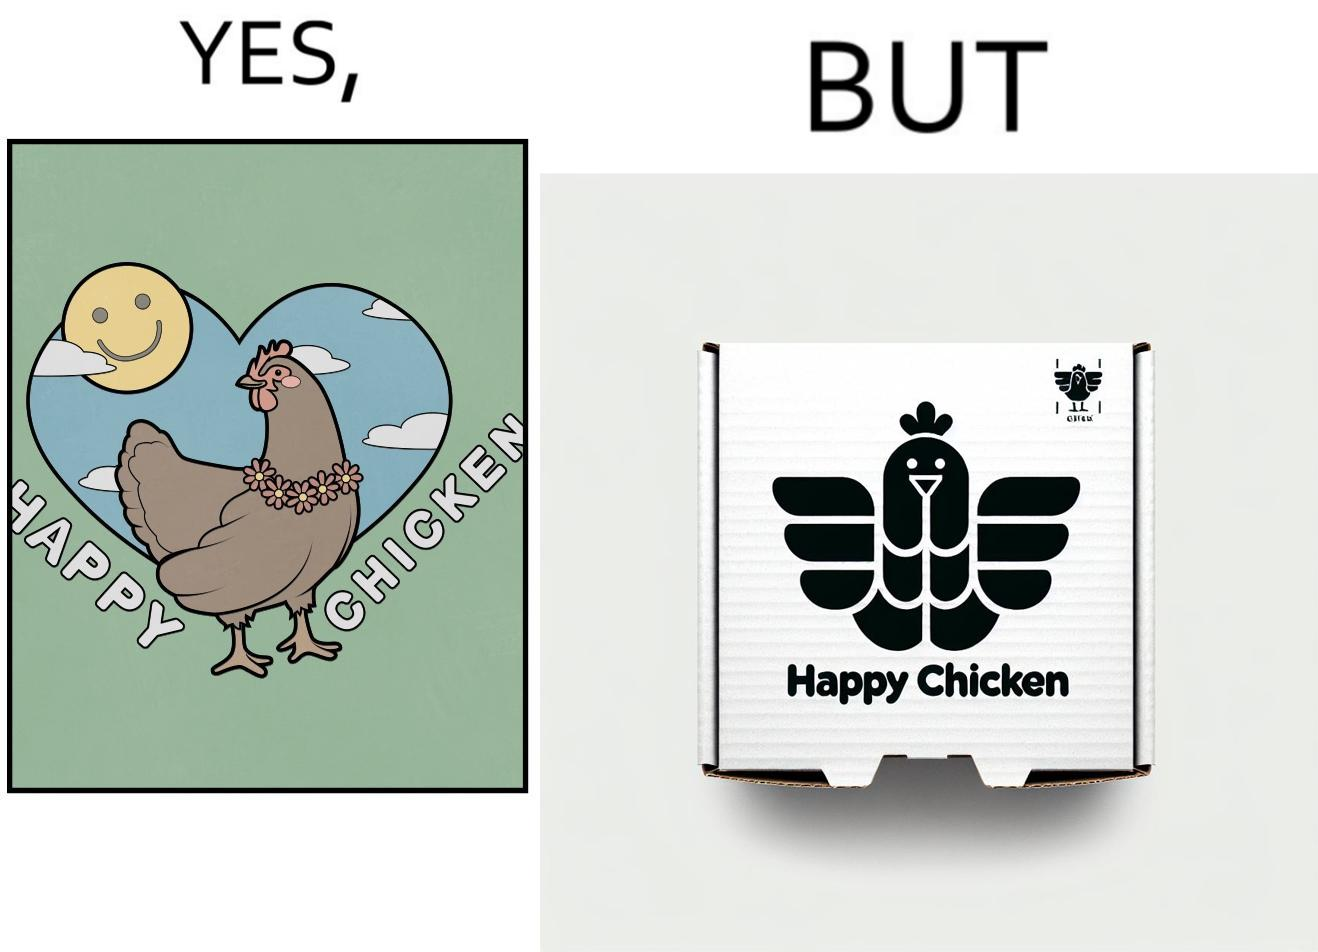Provide a description of this image. The image is ironic, because in the left image as in the logo it shows happy chicken but in the right image the chicken pieces are shown packed in boxes 